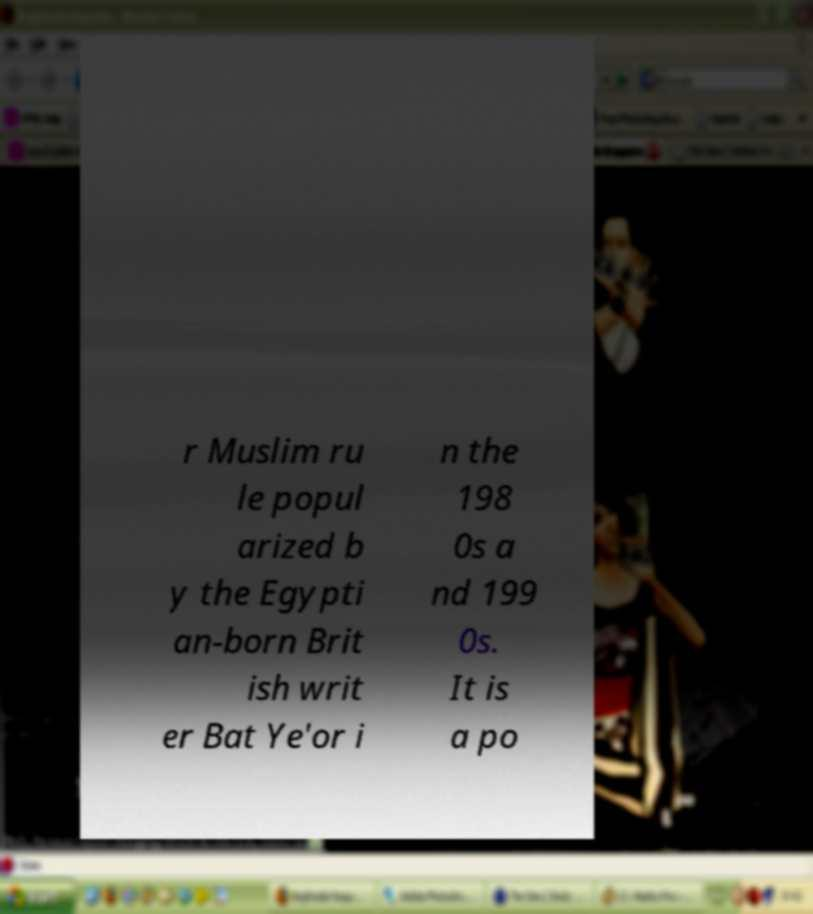Can you accurately transcribe the text from the provided image for me? r Muslim ru le popul arized b y the Egypti an-born Brit ish writ er Bat Ye'or i n the 198 0s a nd 199 0s. It is a po 